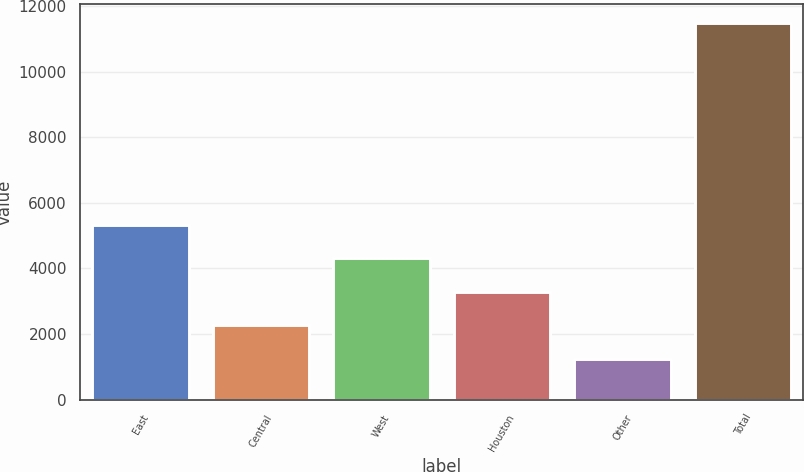Convert chart. <chart><loc_0><loc_0><loc_500><loc_500><bar_chart><fcel>East<fcel>Central<fcel>West<fcel>Houston<fcel>Other<fcel>Total<nl><fcel>5332.2<fcel>2259.3<fcel>4307.9<fcel>3283.6<fcel>1235<fcel>11478<nl></chart> 